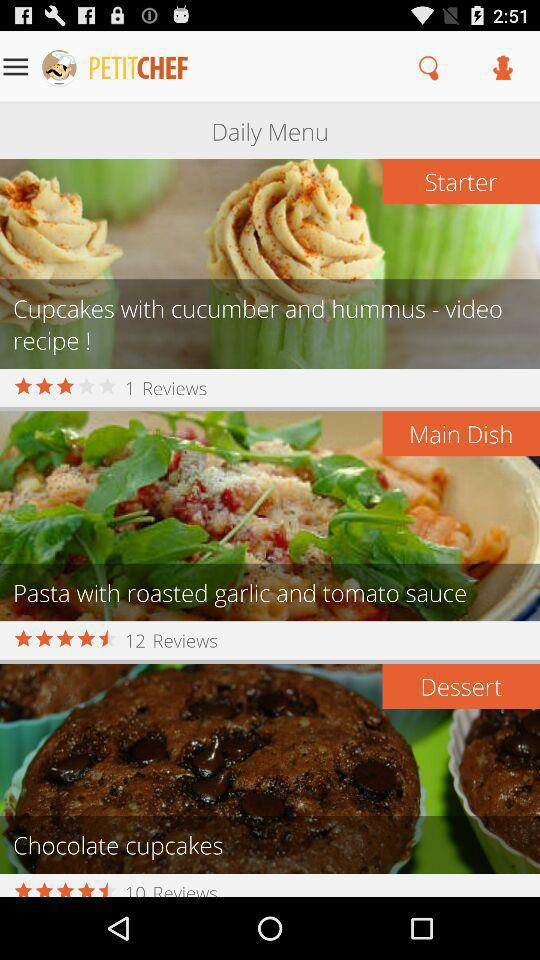How many reviews are on the main dish? There are 12 reviews on the main dish. 